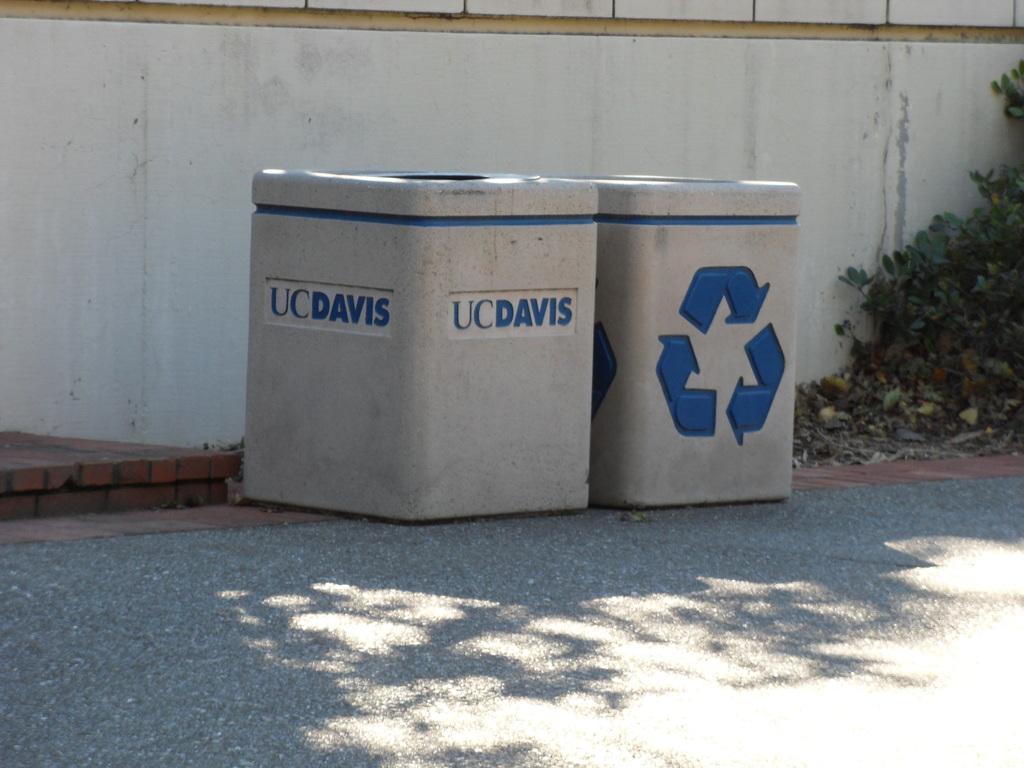Where is this trashcan located?
Offer a terse response. Uc davis. 